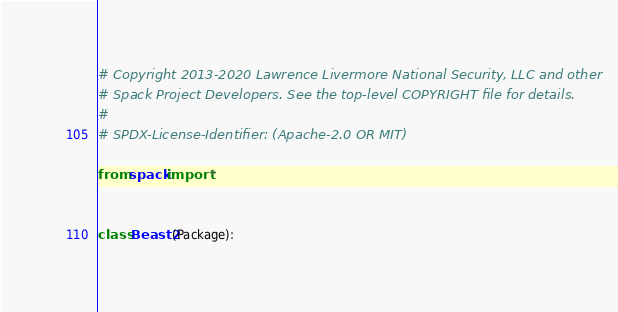Convert code to text. <code><loc_0><loc_0><loc_500><loc_500><_Python_># Copyright 2013-2020 Lawrence Livermore National Security, LLC and other
# Spack Project Developers. See the top-level COPYRIGHT file for details.
#
# SPDX-License-Identifier: (Apache-2.0 OR MIT)

from spack import *


class Beast2(Package):</code> 